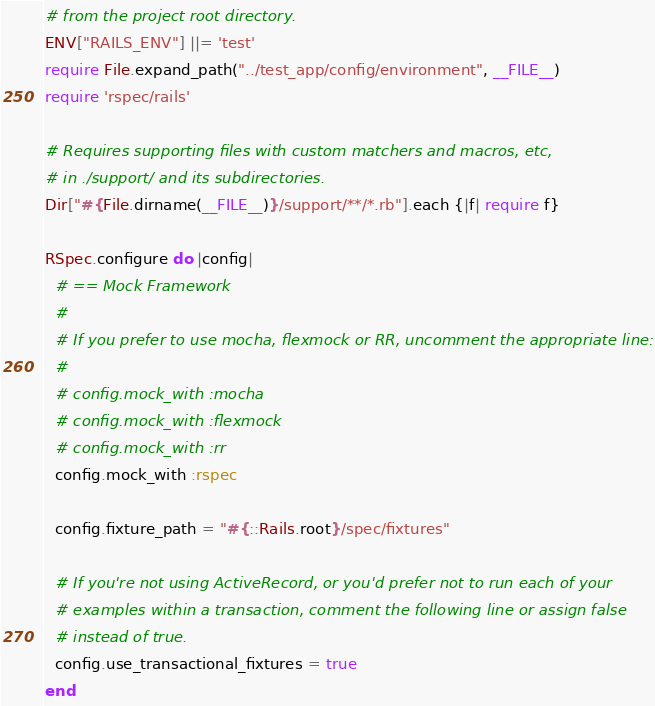<code> <loc_0><loc_0><loc_500><loc_500><_Ruby_># from the project root directory.
ENV["RAILS_ENV"] ||= 'test'
require File.expand_path("../test_app/config/environment", __FILE__)
require 'rspec/rails'

# Requires supporting files with custom matchers and macros, etc,
# in ./support/ and its subdirectories.
Dir["#{File.dirname(__FILE__)}/support/**/*.rb"].each {|f| require f}

RSpec.configure do |config|
  # == Mock Framework
  #
  # If you prefer to use mocha, flexmock or RR, uncomment the appropriate line:
  #
  # config.mock_with :mocha
  # config.mock_with :flexmock
  # config.mock_with :rr
  config.mock_with :rspec

  config.fixture_path = "#{::Rails.root}/spec/fixtures"

  # If you're not using ActiveRecord, or you'd prefer not to run each of your
  # examples within a transaction, comment the following line or assign false
  # instead of true.
  config.use_transactional_fixtures = true
end
</code> 